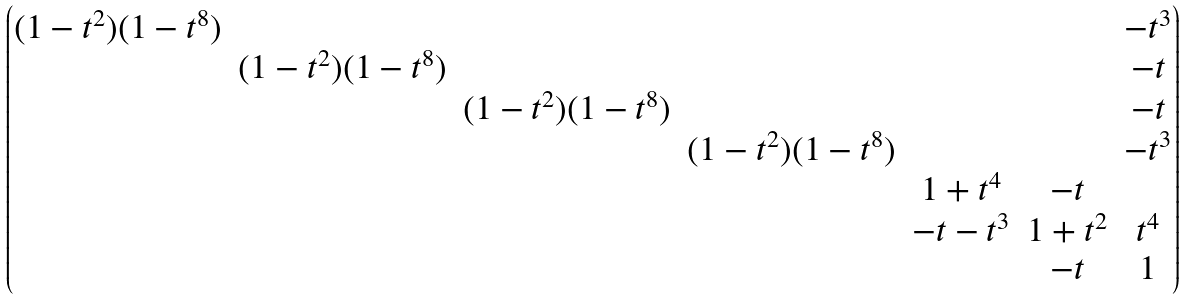<formula> <loc_0><loc_0><loc_500><loc_500>\begin{pmatrix} ( 1 - t ^ { 2 } ) ( 1 - t ^ { 8 } ) & & & & & & - t ^ { 3 } \\ & ( 1 - t ^ { 2 } ) ( 1 - t ^ { 8 } ) & & & & & - t \\ & & ( 1 - t ^ { 2 } ) ( 1 - t ^ { 8 } ) & & & & - t \\ & & & ( 1 - t ^ { 2 } ) ( 1 - t ^ { 8 } ) & & & - t ^ { 3 } \\ & & & & 1 + t ^ { 4 } & - t & \\ & & & & - t - t ^ { 3 } & 1 + t ^ { 2 } & t ^ { 4 } \\ & & & & & - t & 1 \\ \end{pmatrix}</formula> 